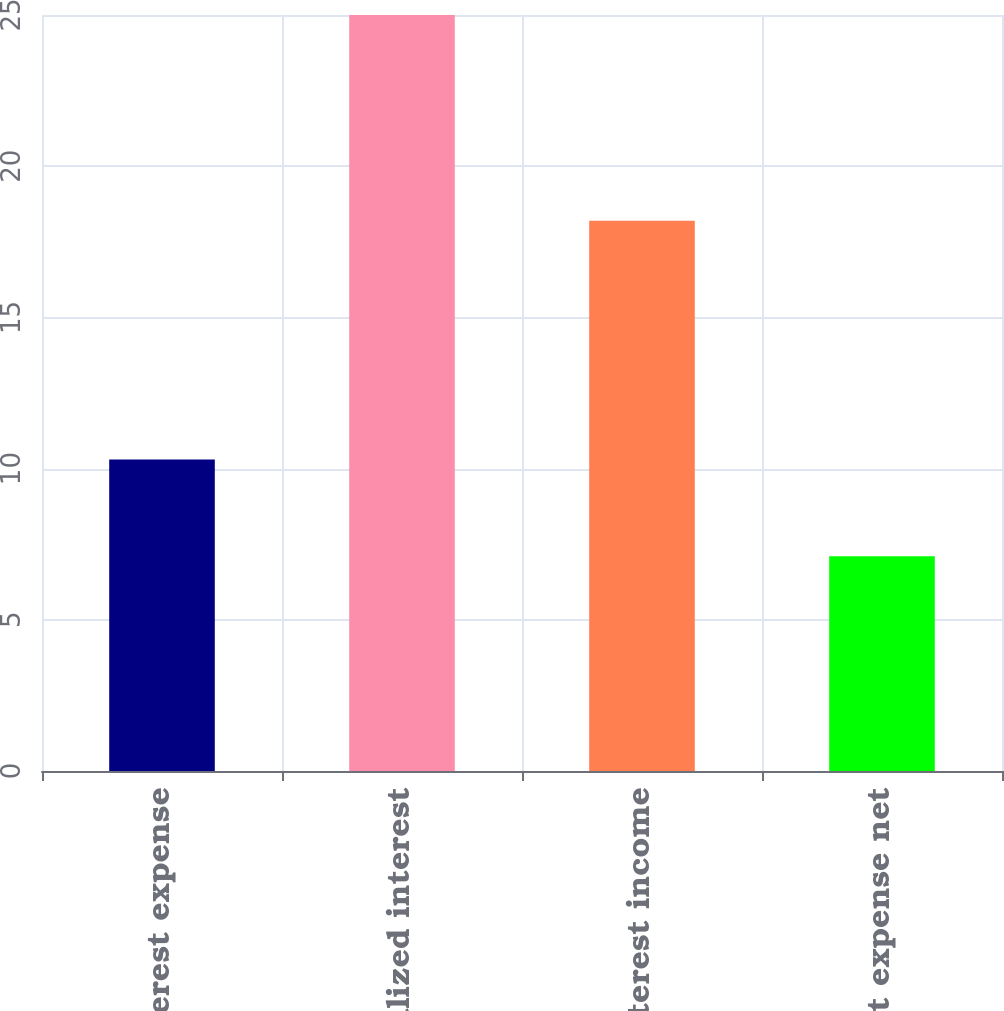<chart> <loc_0><loc_0><loc_500><loc_500><bar_chart><fcel>Interest expense<fcel>Capitalized interest<fcel>Interest income<fcel>Interest expense net<nl><fcel>10.3<fcel>25<fcel>18.2<fcel>7.1<nl></chart> 